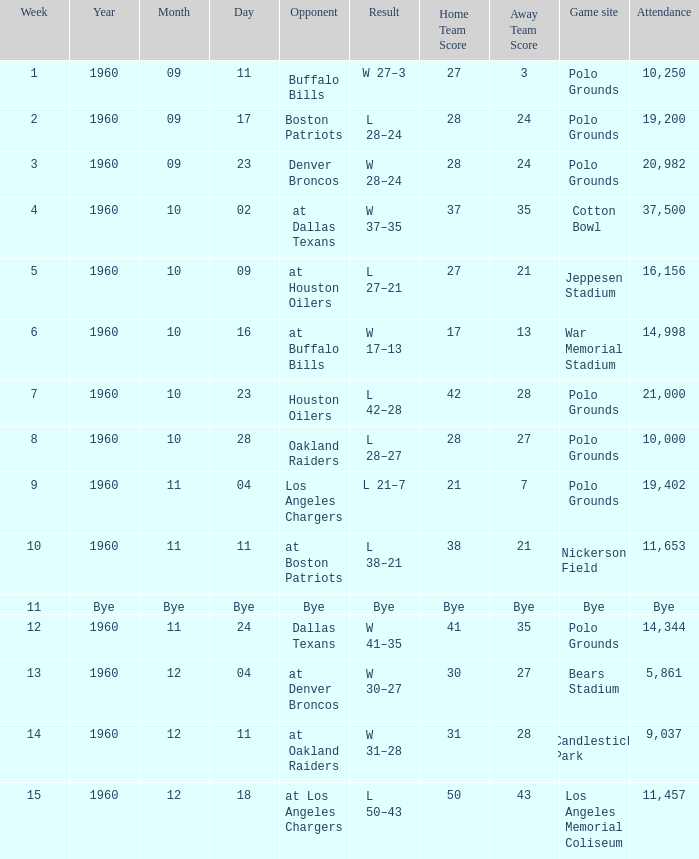What day had 37,500 attending? 1960-10-02. 